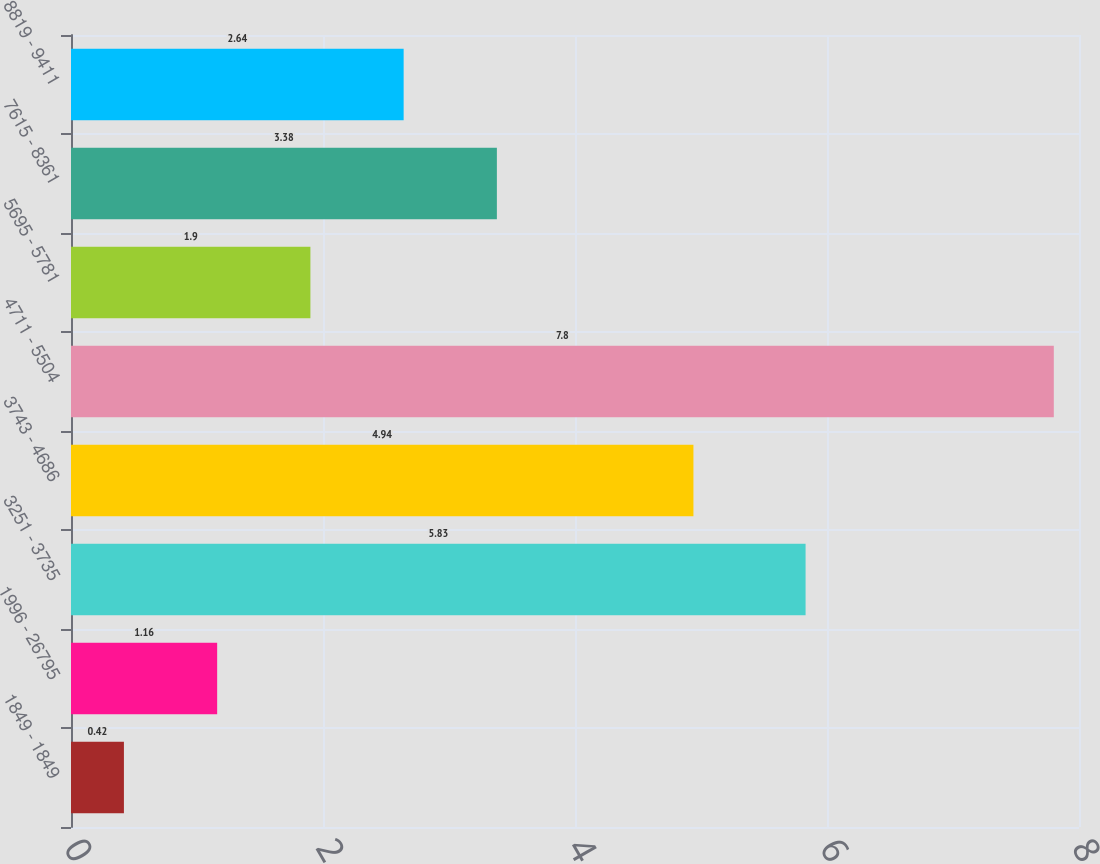Convert chart. <chart><loc_0><loc_0><loc_500><loc_500><bar_chart><fcel>1849 - 1849<fcel>1996 - 26795<fcel>3251 - 3735<fcel>3743 - 4686<fcel>4711 - 5504<fcel>5695 - 5781<fcel>7615 - 8361<fcel>8819 - 9411<nl><fcel>0.42<fcel>1.16<fcel>5.83<fcel>4.94<fcel>7.8<fcel>1.9<fcel>3.38<fcel>2.64<nl></chart> 